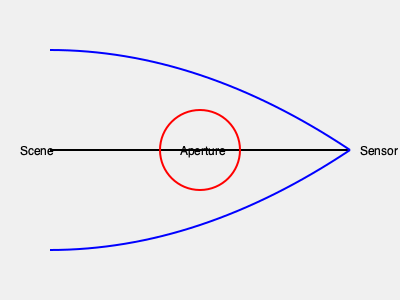In the diagram above, how would decreasing the size of the aperture (represented by the red circle) affect the depth of field in a photograph? To understand the effect of aperture size on depth of field, let's break it down step-by-step:

1. The aperture is the opening in the lens through which light passes. It's represented by the red circle in the diagram.

2. Depth of field refers to the range of distances in a photograph where objects appear acceptably sharp.

3. When we decrease the aperture size:
   a) Less light enters the camera
   b) The cone of light from each point in the scene becomes narrower

4. A narrower cone of light results in a smaller circle of confusion on the sensor for objects that are not in perfect focus.

5. The circle of confusion is the blur spot created by a point source of light when it's not in perfect focus. Smaller circles of confusion appear sharper to the human eye.

6. With a smaller aperture, the circles of confusion for objects slightly in front of or behind the focal plane become smaller.

7. This means that a larger range of distances will appear acceptably sharp in the final image.

Therefore, decreasing the aperture size increases the depth of field in a photograph, making more of the scene appear in focus from foreground to background.

This principle is why landscape photographers often use small apertures (high f-numbers) to keep both near and far objects sharp, while portrait photographers might use larger apertures (low f-numbers) to blur the background and isolate the subject.
Answer: Increase depth of field 